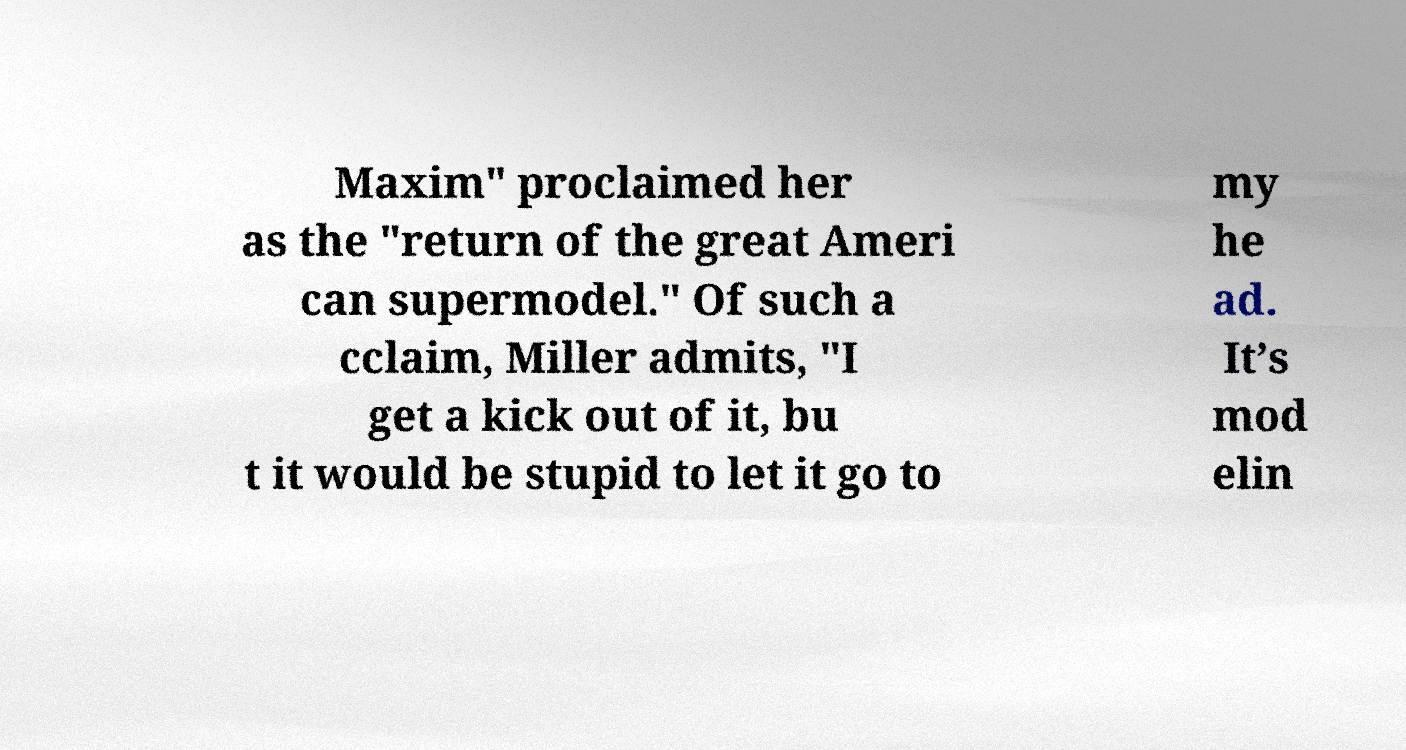Could you extract and type out the text from this image? Maxim" proclaimed her as the "return of the great Ameri can supermodel." Of such a cclaim, Miller admits, "I get a kick out of it, bu t it would be stupid to let it go to my he ad. It’s mod elin 